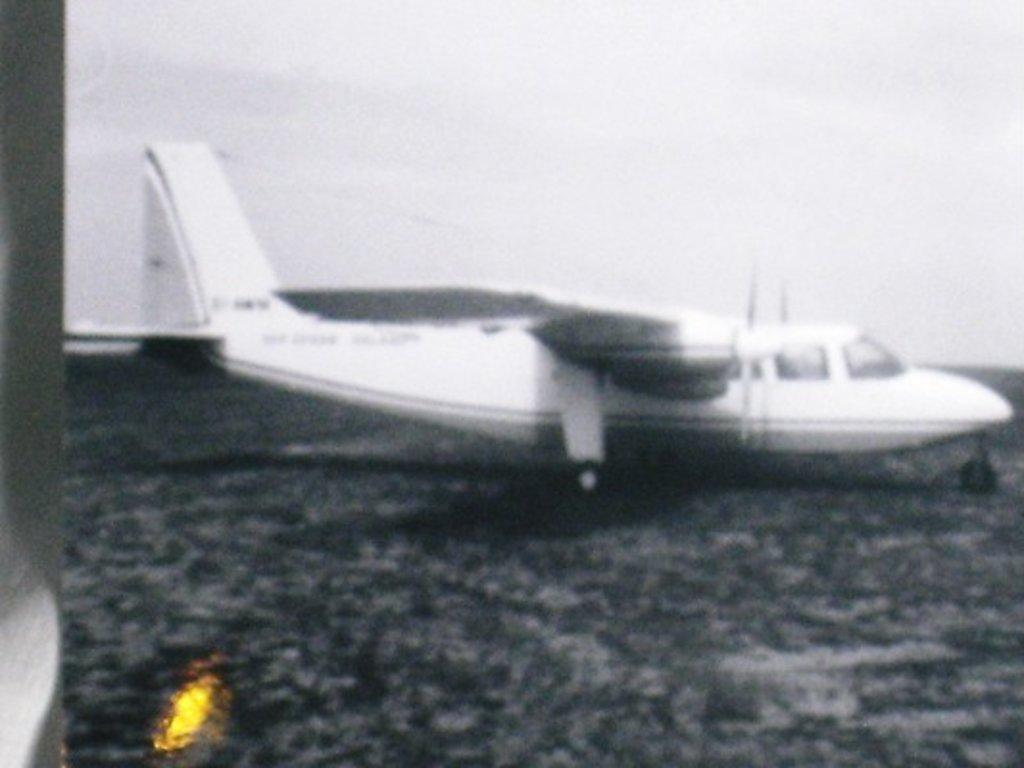What is the color scheme of the image? The image is black and white. What is the main subject of the image? There is an aircraft in the image. Can you describe any other elements in the image? There is a light on the left side of the image. How many eggs are visible in the image? There are no eggs present in the image. What type of spacecraft is shown in the image? The image does not depict a spacecraft; it features an aircraft. 